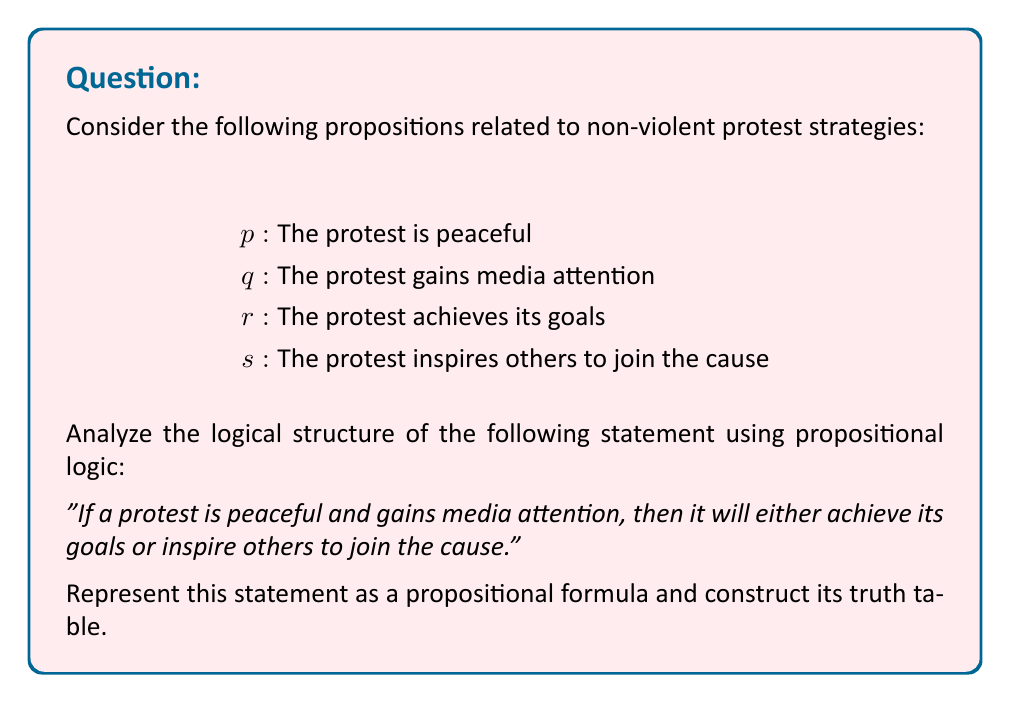Can you answer this question? Let's approach this step-by-step:

1) First, we need to translate the given statement into a propositional formula:

   $(p \land q) \rightarrow (r \lor s)$

2) To construct the truth table, we need to consider all possible combinations of truth values for $p$, $q$, $r$, and $s$. There will be $2^4 = 16$ rows in our truth table.

3) We'll evaluate the formula from left to right:
   a) Evaluate $p \land q$
   b) Evaluate $r \lor s$
   c) Evaluate the implication $(p \land q) \rightarrow (r \lor s)$

4) Here's the truth table:

   $$
   \begin{array}{|c|c|c|c||c|c||c|}
   \hline
   p & q & r & s & p \land q & r \lor s & (p \land q) \rightarrow (r \lor s) \\
   \hline
   T & T & T & T & T & T & T \\
   T & T & T & F & T & T & T \\
   T & T & F & T & T & T & T \\
   T & T & F & F & T & F & F \\
   T & F & T & T & F & T & T \\
   T & F & T & F & F & T & T \\
   T & F & F & T & F & T & T \\
   T & F & F & F & F & F & T \\
   F & T & T & T & F & T & T \\
   F & T & T & F & F & T & T \\
   F & T & F & T & F & T & T \\
   F & T & F & F & F & F & T \\
   F & F & T & T & F & T & T \\
   F & F & T & F & F & T & T \\
   F & F & F & T & F & T & T \\
   F & F & F & F & F & F & T \\
   \hline
   \end{array}
   $$

5) From the truth table, we can observe that the statement is false only when $p$ and $q$ are true (the protest is peaceful and gains media attention), but both $r$ and $s$ are false (it neither achieves its goals nor inspires others).

6) This logical structure emphasizes the importance of peaceful protests and media attention in achieving goals or inspiring others, aligning with the given persona's belief in non-violence and harmony.
Answer: $(p \land q) \rightarrow (r \lor s)$ 